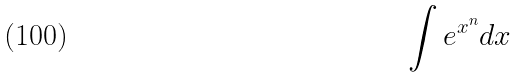Convert formula to latex. <formula><loc_0><loc_0><loc_500><loc_500>\int e ^ { x ^ { n } } d x</formula> 